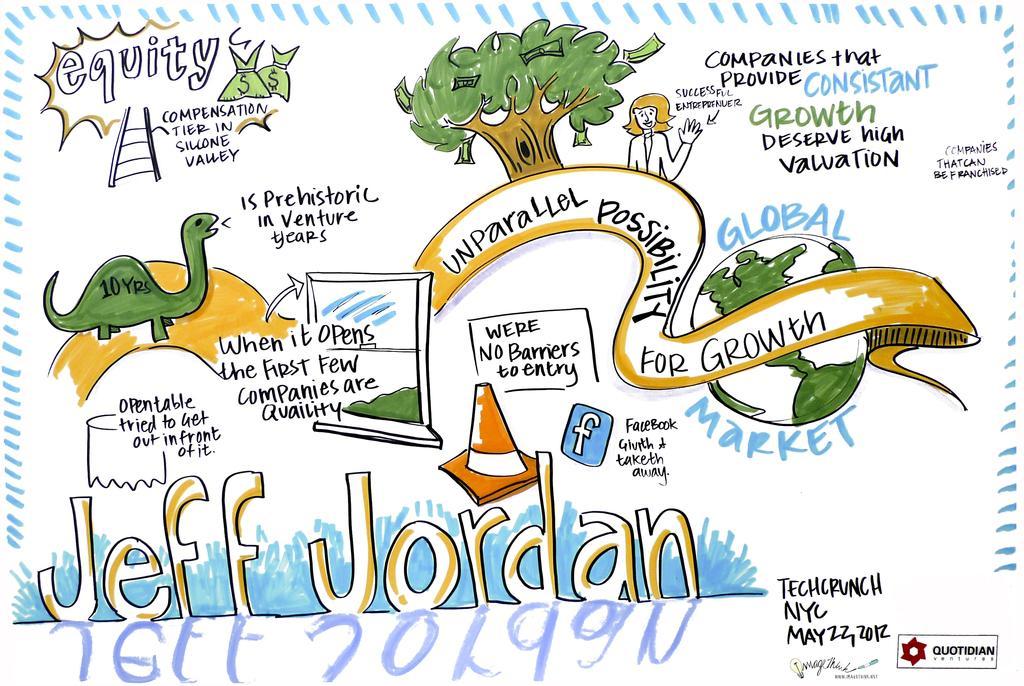Describe this image in one or two sentences. This is the cartoon image in which there is some text written and there are images of a tree. 